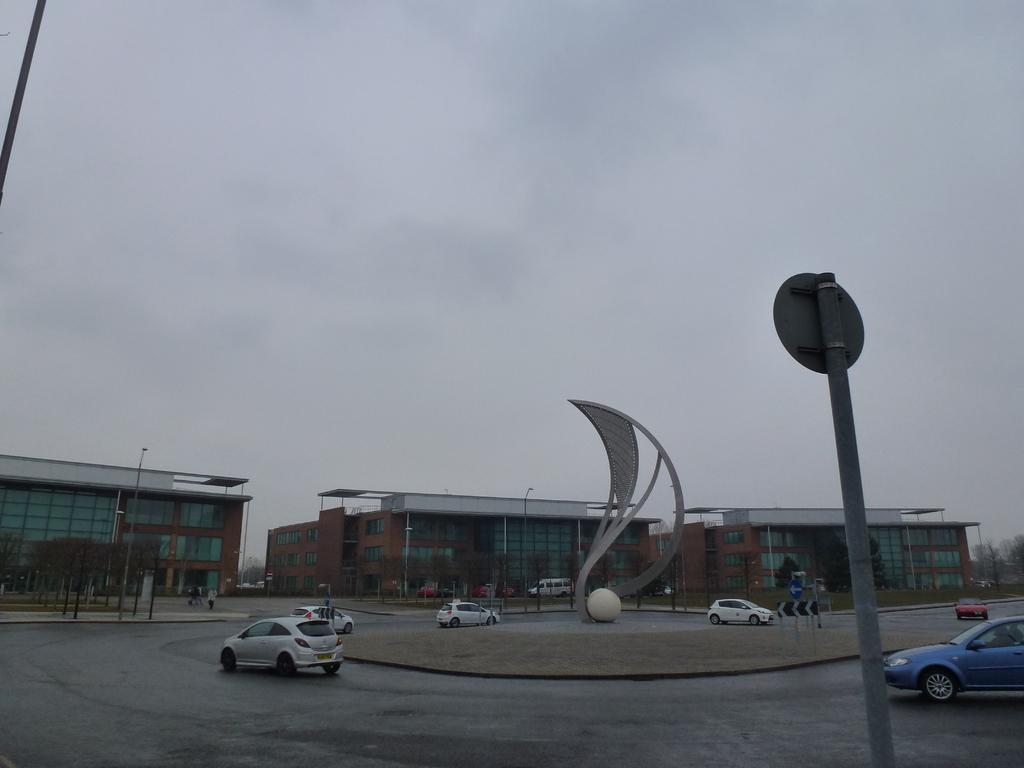Can you describe this image briefly? In this image, we can see some cars on the road. There is a sign board on the right side of the image. There are buildings in the middle of the image. In the background of the image, there is a sky. 